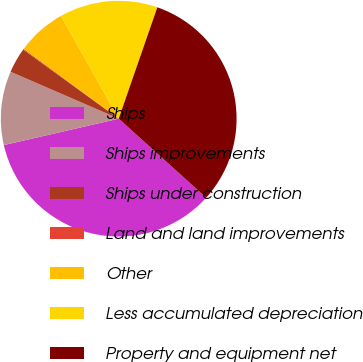Convert chart. <chart><loc_0><loc_0><loc_500><loc_500><pie_chart><fcel>Ships<fcel>Ships improvements<fcel>Ships under construction<fcel>Land and land improvements<fcel>Other<fcel>Less accumulated depreciation<fcel>Property and equipment net<nl><fcel>34.71%<fcel>10.11%<fcel>3.45%<fcel>0.12%<fcel>6.78%<fcel>13.45%<fcel>31.38%<nl></chart> 